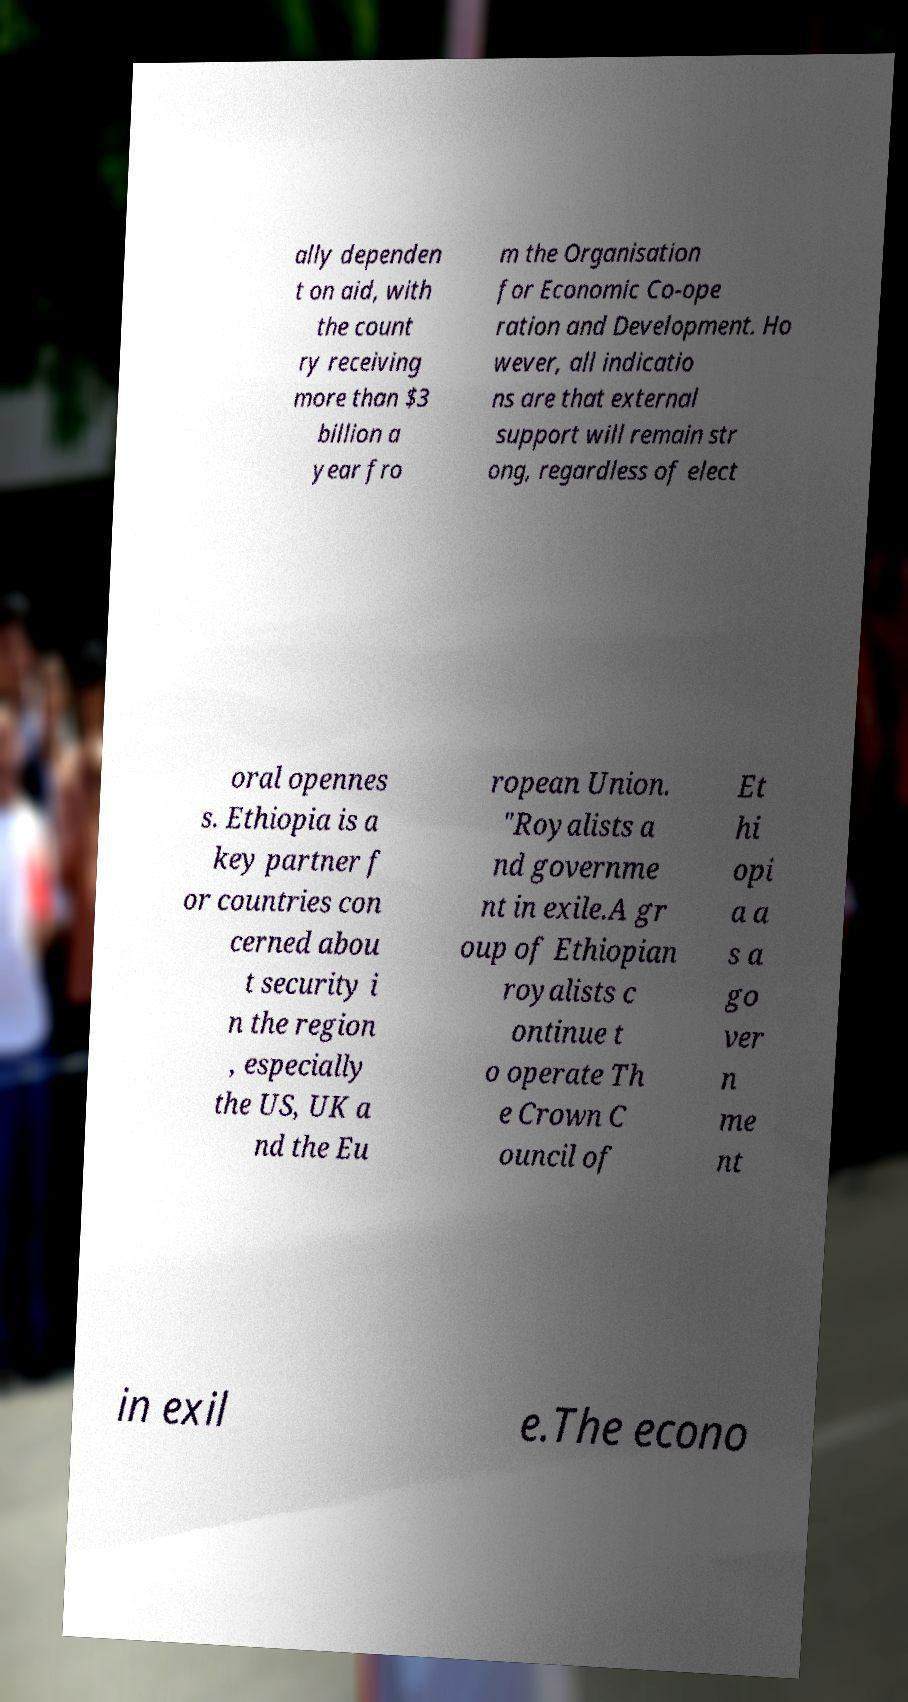Can you accurately transcribe the text from the provided image for me? ally dependen t on aid, with the count ry receiving more than $3 billion a year fro m the Organisation for Economic Co-ope ration and Development. Ho wever, all indicatio ns are that external support will remain str ong, regardless of elect oral opennes s. Ethiopia is a key partner f or countries con cerned abou t security i n the region , especially the US, UK a nd the Eu ropean Union. "Royalists a nd governme nt in exile.A gr oup of Ethiopian royalists c ontinue t o operate Th e Crown C ouncil of Et hi opi a a s a go ver n me nt in exil e.The econo 